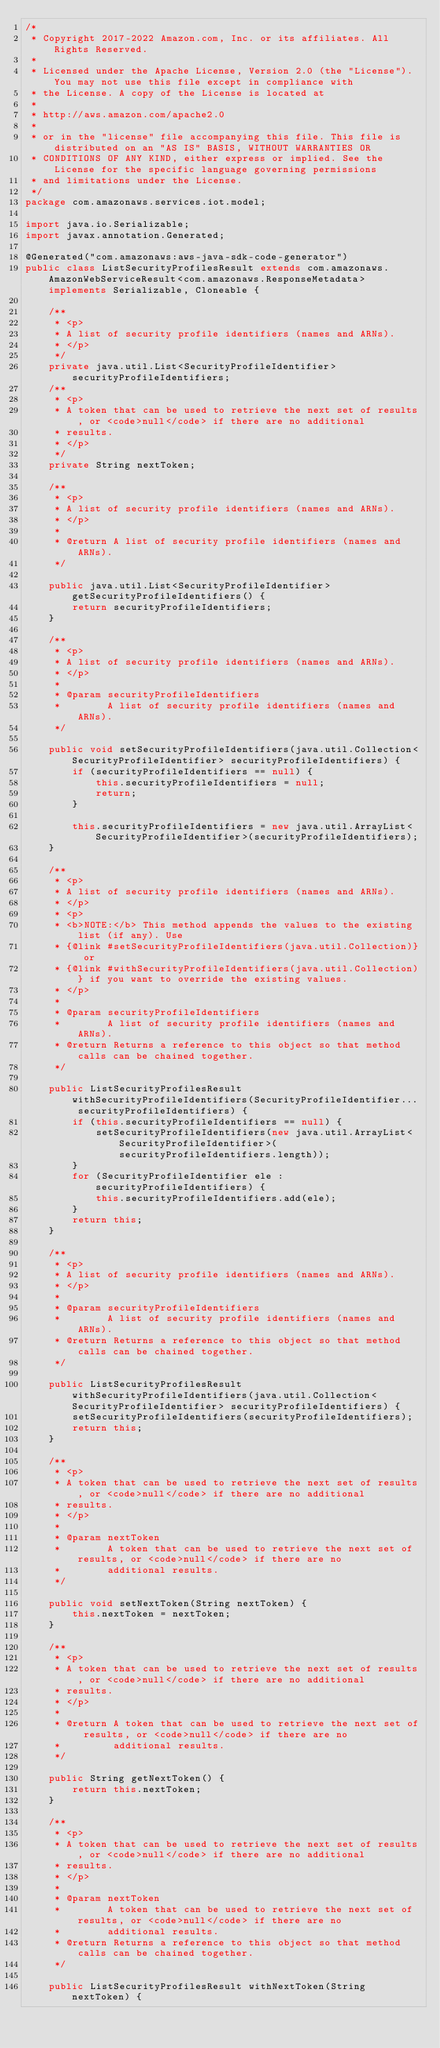<code> <loc_0><loc_0><loc_500><loc_500><_Java_>/*
 * Copyright 2017-2022 Amazon.com, Inc. or its affiliates. All Rights Reserved.
 * 
 * Licensed under the Apache License, Version 2.0 (the "License"). You may not use this file except in compliance with
 * the License. A copy of the License is located at
 * 
 * http://aws.amazon.com/apache2.0
 * 
 * or in the "license" file accompanying this file. This file is distributed on an "AS IS" BASIS, WITHOUT WARRANTIES OR
 * CONDITIONS OF ANY KIND, either express or implied. See the License for the specific language governing permissions
 * and limitations under the License.
 */
package com.amazonaws.services.iot.model;

import java.io.Serializable;
import javax.annotation.Generated;

@Generated("com.amazonaws:aws-java-sdk-code-generator")
public class ListSecurityProfilesResult extends com.amazonaws.AmazonWebServiceResult<com.amazonaws.ResponseMetadata> implements Serializable, Cloneable {

    /**
     * <p>
     * A list of security profile identifiers (names and ARNs).
     * </p>
     */
    private java.util.List<SecurityProfileIdentifier> securityProfileIdentifiers;
    /**
     * <p>
     * A token that can be used to retrieve the next set of results, or <code>null</code> if there are no additional
     * results.
     * </p>
     */
    private String nextToken;

    /**
     * <p>
     * A list of security profile identifiers (names and ARNs).
     * </p>
     * 
     * @return A list of security profile identifiers (names and ARNs).
     */

    public java.util.List<SecurityProfileIdentifier> getSecurityProfileIdentifiers() {
        return securityProfileIdentifiers;
    }

    /**
     * <p>
     * A list of security profile identifiers (names and ARNs).
     * </p>
     * 
     * @param securityProfileIdentifiers
     *        A list of security profile identifiers (names and ARNs).
     */

    public void setSecurityProfileIdentifiers(java.util.Collection<SecurityProfileIdentifier> securityProfileIdentifiers) {
        if (securityProfileIdentifiers == null) {
            this.securityProfileIdentifiers = null;
            return;
        }

        this.securityProfileIdentifiers = new java.util.ArrayList<SecurityProfileIdentifier>(securityProfileIdentifiers);
    }

    /**
     * <p>
     * A list of security profile identifiers (names and ARNs).
     * </p>
     * <p>
     * <b>NOTE:</b> This method appends the values to the existing list (if any). Use
     * {@link #setSecurityProfileIdentifiers(java.util.Collection)} or
     * {@link #withSecurityProfileIdentifiers(java.util.Collection)} if you want to override the existing values.
     * </p>
     * 
     * @param securityProfileIdentifiers
     *        A list of security profile identifiers (names and ARNs).
     * @return Returns a reference to this object so that method calls can be chained together.
     */

    public ListSecurityProfilesResult withSecurityProfileIdentifiers(SecurityProfileIdentifier... securityProfileIdentifiers) {
        if (this.securityProfileIdentifiers == null) {
            setSecurityProfileIdentifiers(new java.util.ArrayList<SecurityProfileIdentifier>(securityProfileIdentifiers.length));
        }
        for (SecurityProfileIdentifier ele : securityProfileIdentifiers) {
            this.securityProfileIdentifiers.add(ele);
        }
        return this;
    }

    /**
     * <p>
     * A list of security profile identifiers (names and ARNs).
     * </p>
     * 
     * @param securityProfileIdentifiers
     *        A list of security profile identifiers (names and ARNs).
     * @return Returns a reference to this object so that method calls can be chained together.
     */

    public ListSecurityProfilesResult withSecurityProfileIdentifiers(java.util.Collection<SecurityProfileIdentifier> securityProfileIdentifiers) {
        setSecurityProfileIdentifiers(securityProfileIdentifiers);
        return this;
    }

    /**
     * <p>
     * A token that can be used to retrieve the next set of results, or <code>null</code> if there are no additional
     * results.
     * </p>
     * 
     * @param nextToken
     *        A token that can be used to retrieve the next set of results, or <code>null</code> if there are no
     *        additional results.
     */

    public void setNextToken(String nextToken) {
        this.nextToken = nextToken;
    }

    /**
     * <p>
     * A token that can be used to retrieve the next set of results, or <code>null</code> if there are no additional
     * results.
     * </p>
     * 
     * @return A token that can be used to retrieve the next set of results, or <code>null</code> if there are no
     *         additional results.
     */

    public String getNextToken() {
        return this.nextToken;
    }

    /**
     * <p>
     * A token that can be used to retrieve the next set of results, or <code>null</code> if there are no additional
     * results.
     * </p>
     * 
     * @param nextToken
     *        A token that can be used to retrieve the next set of results, or <code>null</code> if there are no
     *        additional results.
     * @return Returns a reference to this object so that method calls can be chained together.
     */

    public ListSecurityProfilesResult withNextToken(String nextToken) {</code> 